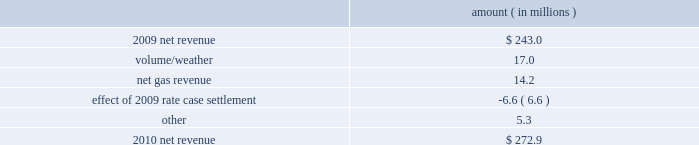Entergy new orleans , inc .
Management 2019s financial discussion and analysis the volume/weather variance is primarily due to an increase in electricity usage in the residential and commercial sectors due in part to a 4% ( 4 % ) increase in the average number of residential customers and a 3% ( 3 % ) increase in the average number of commercial customers , partially offset by the effect of less favorable weather on residential sales .
Gross operating revenues gross operating revenues decreased primarily due to : a decrease of $ 16.2 million in electric fuel cost recovery revenues due to lower fuel rates ; a decrease of $ 15.4 million in gross gas revenues primarily due to lower fuel cost recovery revenues as a result of lower fuel rates and the effect of milder weather ; and formula rate plan decreases effective october 2010 and october 2011 , as discussed above .
The decrease was partially offset by an increase in gross wholesale revenue due to increased sales to affiliated customers and more favorable volume/weather , as discussed above .
2010 compared to 2009 net revenue consists of operating revenues net of : 1 ) fuel , fuel-related expenses , and gas purchased for resale , 2 ) purchased power expenses , and 3 ) other regulatory charges ( credits ) .
Following is an analysis of the change in net revenue comparing 2010 to 2009 .
Amount ( in millions ) .
The volume/weather variance is primarily due to an increase of 348 gwh , or 7% ( 7 % ) , in billed retail electricity usage primarily due to more favorable weather compared to last year .
The net gas revenue variance is primarily due to more favorable weather compared to last year , along with the recognition of a gas regulatory asset associated with the settlement of entergy new orleans 2019s electric and gas formula rate plans .
See note 2 to the financial statements for further discussion of the formula rate plan settlement .
The effect of 2009 rate case settlement variance results from the april 2009 settlement of entergy new orleans 2019s rate case , and includes the effects of realigning non-fuel costs associated with the operation of grand gulf from the fuel adjustment clause to electric base rates effective june 2009 .
See note 2 to the financial statements for further discussion of the rate case settlement .
Other income statement variances 2011 compared to 2010 other operation and maintenance expenses decreased primarily due to the deferral in 2011 of $ 13.4 million of 2010 michoud plant maintenance costs pursuant to the settlement of entergy new orleans 2019s 2010 test year formula rate plan filing approved by the city council in september 2011 and a decrease of $ 8.0 million in fossil- fueled generation expenses due to higher plant outage costs in 2010 due to a greater scope of work at the michoud plant .
See note 2 to the financial statements for more discussion of the 2010 test year formula rate plan filing. .
What was the amount of the sum of the factors that contributed to the decrease in the gross operating revenues? 
Computations: (15.4 + 16.2)
Answer: 31.6. 